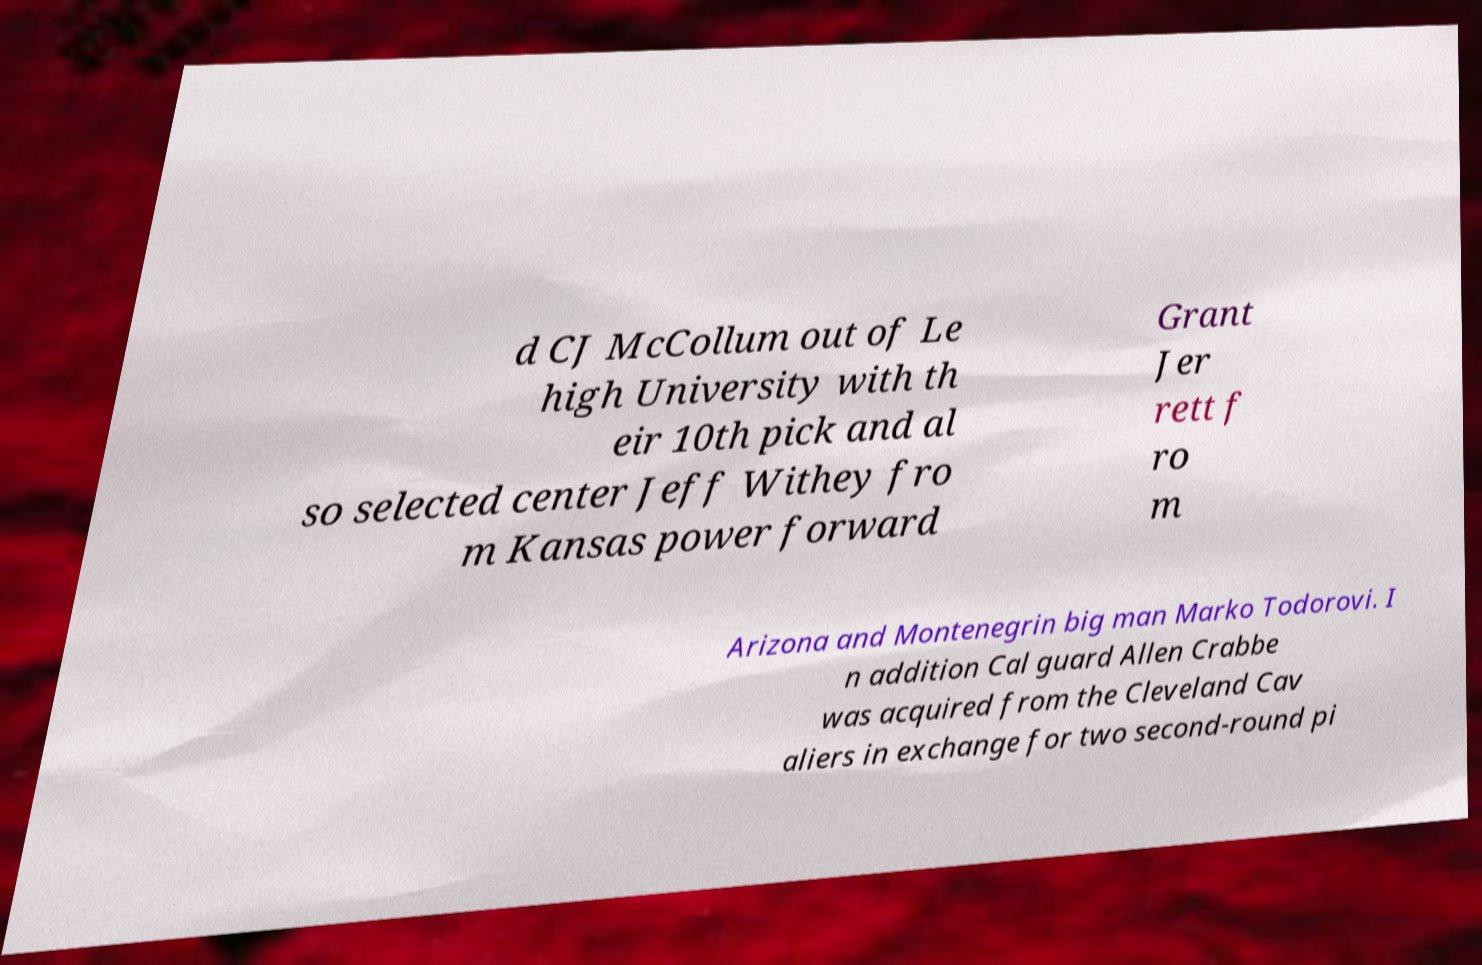Please identify and transcribe the text found in this image. d CJ McCollum out of Le high University with th eir 10th pick and al so selected center Jeff Withey fro m Kansas power forward Grant Jer rett f ro m Arizona and Montenegrin big man Marko Todorovi. I n addition Cal guard Allen Crabbe was acquired from the Cleveland Cav aliers in exchange for two second-round pi 